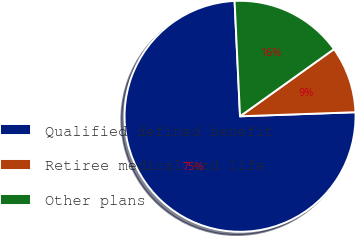<chart> <loc_0><loc_0><loc_500><loc_500><pie_chart><fcel>Qualified defined benefit<fcel>Retiree medical and life<fcel>Other plans<nl><fcel>74.81%<fcel>9.32%<fcel>15.87%<nl></chart> 